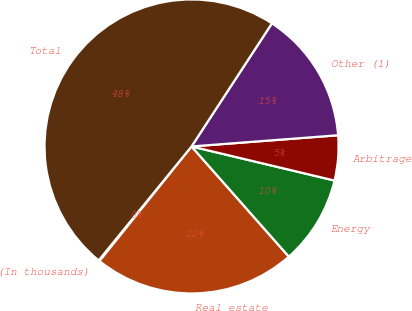Convert chart to OTSL. <chart><loc_0><loc_0><loc_500><loc_500><pie_chart><fcel>(In thousands)<fcel>Real estate<fcel>Energy<fcel>Arbitrage<fcel>Other (1)<fcel>Total<nl><fcel>0.12%<fcel>22.28%<fcel>9.76%<fcel>4.94%<fcel>14.58%<fcel>48.32%<nl></chart> 